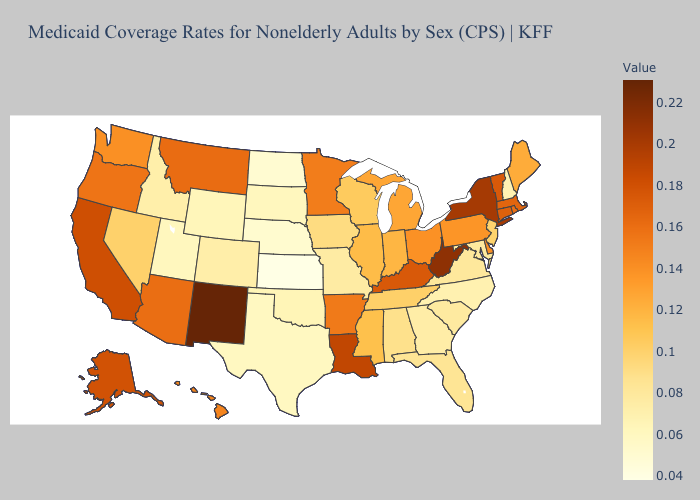Does North Dakota have the lowest value in the USA?
Quick response, please. No. Which states hav the highest value in the Northeast?
Short answer required. New York. Does New Mexico have the highest value in the USA?
Give a very brief answer. Yes. Does Maryland have a higher value than Nebraska?
Answer briefly. Yes. Does Washington have the lowest value in the West?
Keep it brief. No. 